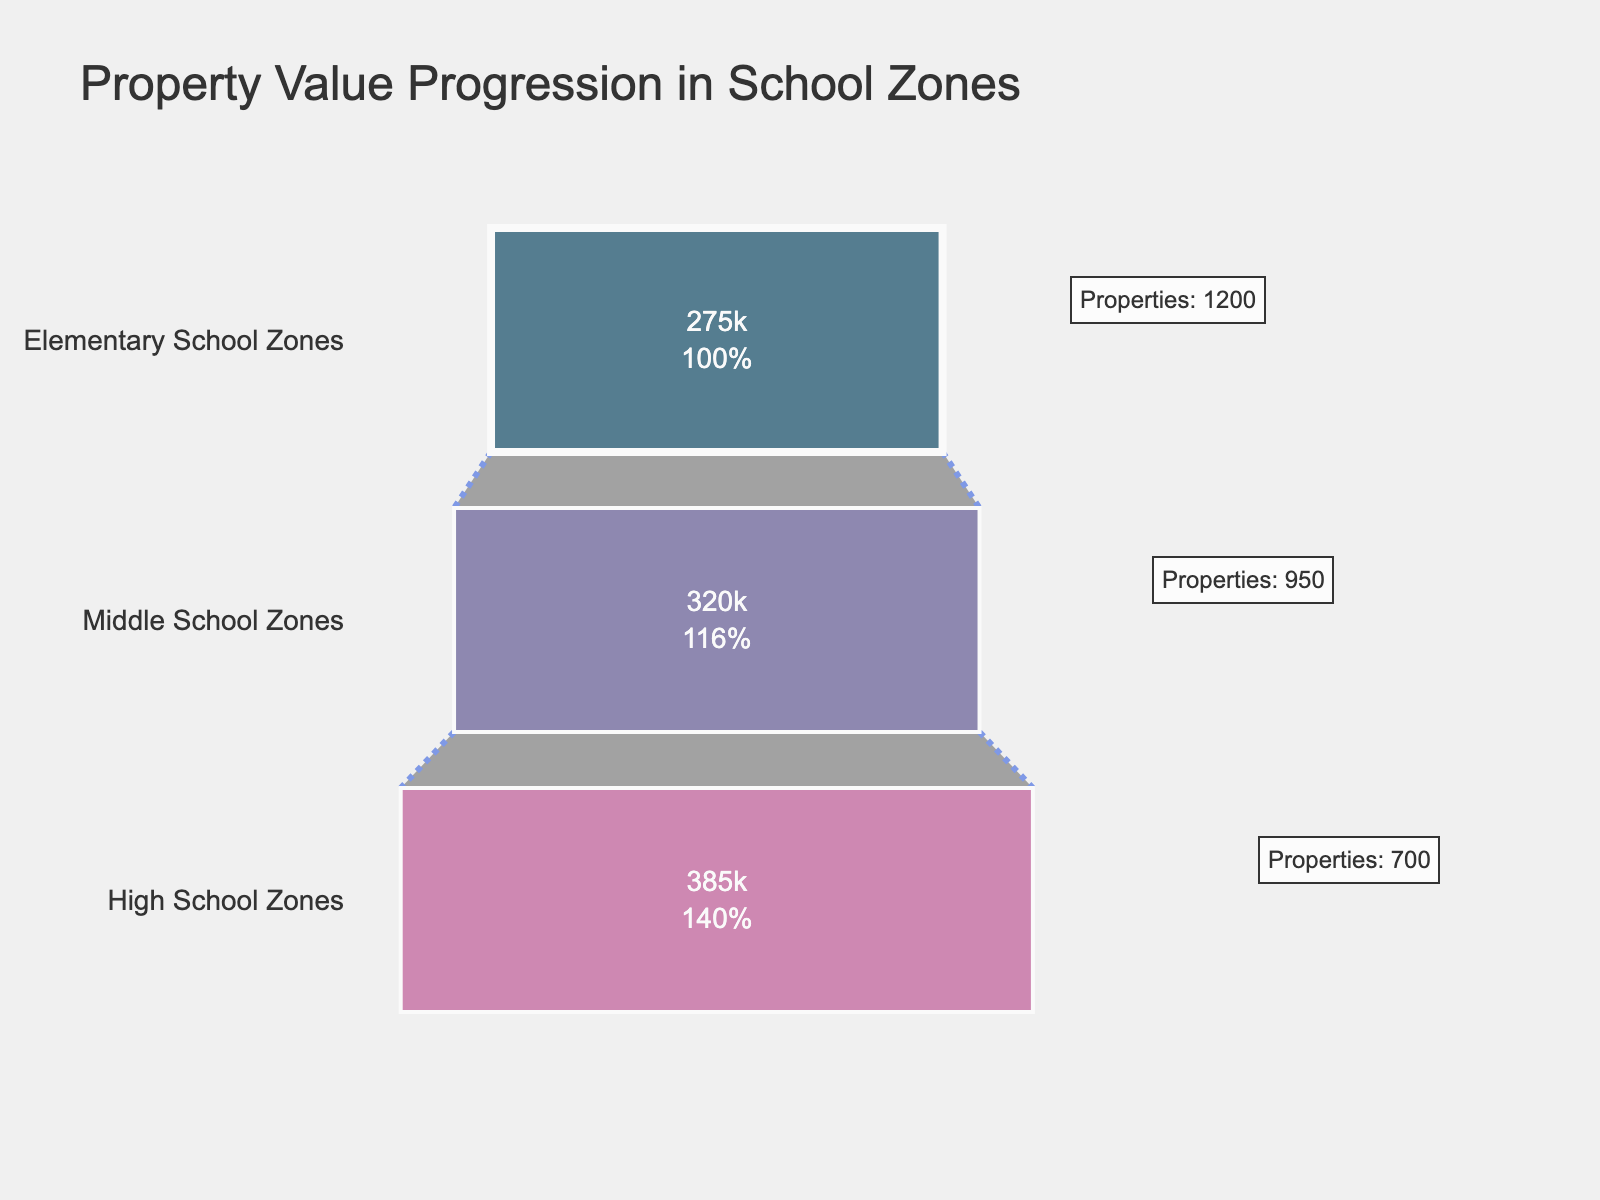What's the title of the funnel chart? The title can be seen at the top of the chart, it helps in understanding the overall context of the figure.
Answer: Property Value Progression in School Zones What stage has the most number of properties? By looking at the annotations next to each stage, we see the number of properties: Elementary School Zones (1200), Middle School Zones (950), High School Zones (700). The stage with 1200 properties is Elementary School Zones.
Answer: Elementary School Zones What's the average property value in Middle School Zones? The average property values are listed inside the funnel segments. For Middle School Zones, it is $320,000.
Answer: $320,000 What is the increase in average property value from Elementary to High School Zones? First identify the average property values: Elementary ($275,000), Middle ($320,000), High ($385,000). Subtraction gives: $385,000 - $275,000 = $110,000.
Answer: $110,000 By how much does the number of properties decrease from Elementary School to Middle School Zones? Number of properties: Elementary (1200), Middle (950). The decrease is 1200 - 950 = 250.
Answer: 250 Which zone has the highest average property value? Check the average property values in each zone: Elementary ($275,000), Middle ($320,000), High ($385,000). The highest value is in High School Zones.
Answer: High School Zones What percentage of initial properties are in High School Zones? The figure shows the percentage of initial (Elementary) properties for each stage. For High School Zones, we see 700 properties out of 1200. Percent: (700/1200) * 100 ≈ 58.33%.
Answer: 58.33% What's the total number of properties across all zones? Add the number of properties from each zone: 1200 (Elementary) + 950 (Middle) + 700 (High) = 2850 properties.
Answer: 2850 What is the color of the segment representing Middle School Zones? The color legend or the figure itself shows the segment's color. Middle School Zones are represented by a specific middle-purple shade.
Answer: Purple Is the average property value progression visually consistent across the stages? By observing the visual segments, we can determine the progression. Each subsequent segment is larger: $275,000 to $320,000 to $385,000. This shows a consistent increase.
Answer: Yes 